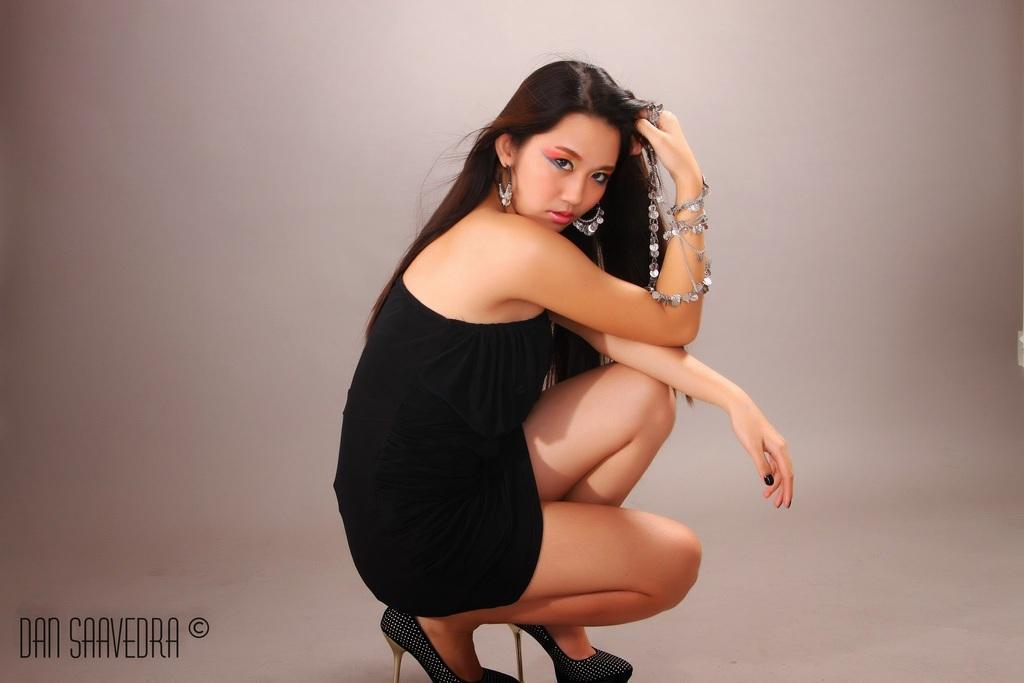Can you describe this image briefly? In this picture we can see a woman on a surface, in the bottom left we can see some text on it. 